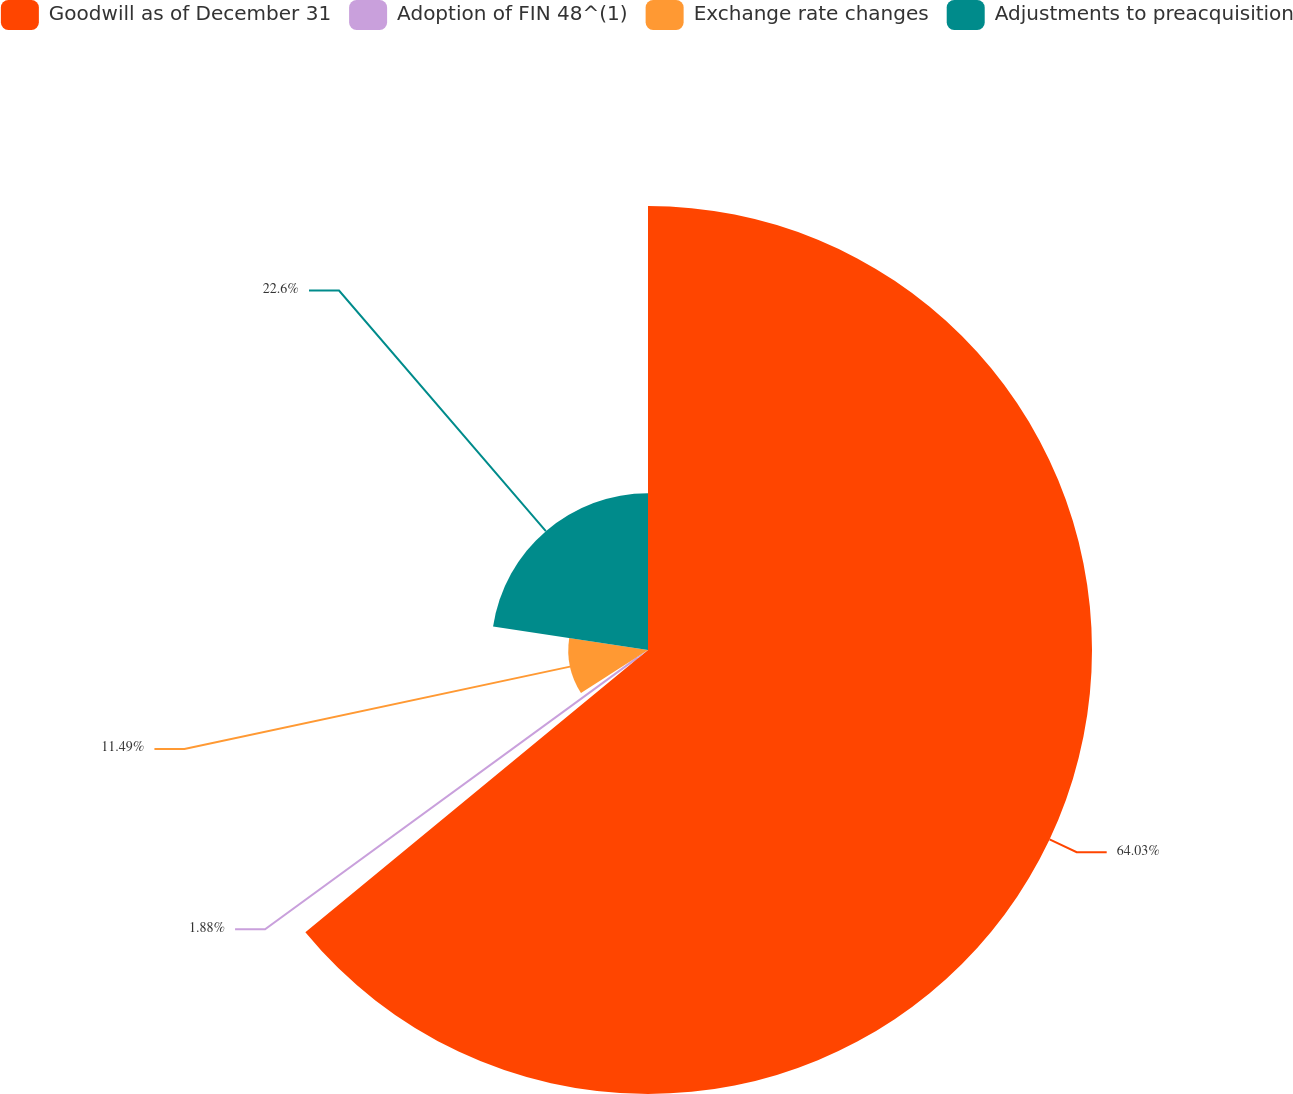Convert chart. <chart><loc_0><loc_0><loc_500><loc_500><pie_chart><fcel>Goodwill as of December 31<fcel>Adoption of FIN 48^(1)<fcel>Exchange rate changes<fcel>Adjustments to preacquisition<nl><fcel>64.03%<fcel>1.88%<fcel>11.49%<fcel>22.6%<nl></chart> 